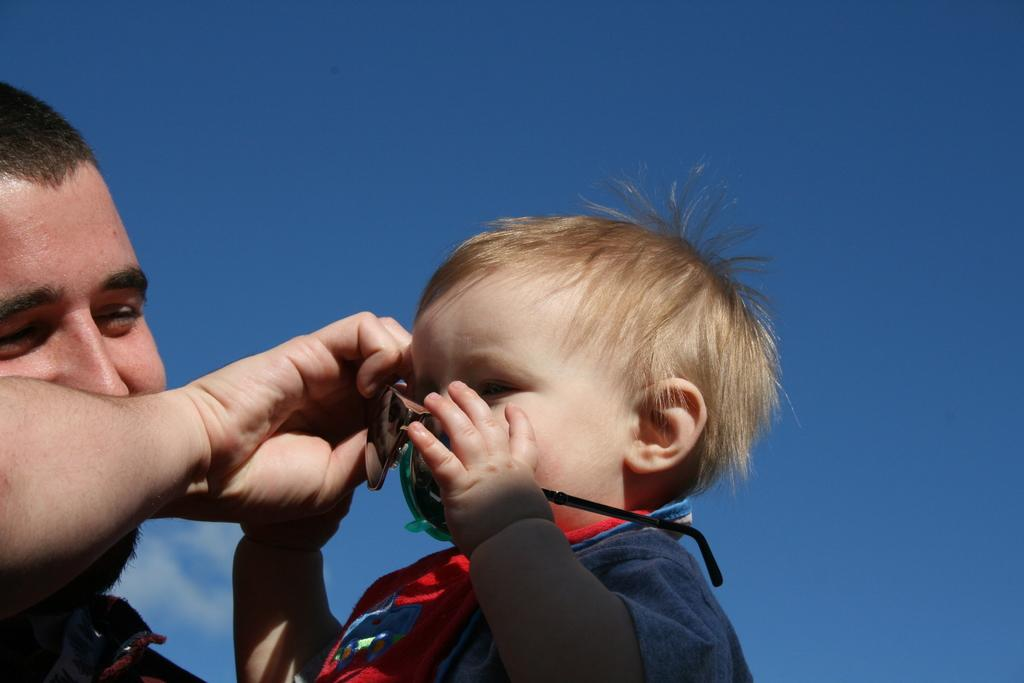Who is present in the image? There is a boy and a person in the image. Can you describe the boy in the image? The facts provided do not give specific details about the boy's appearance or actions. What is visible in the background of the image? The sky is visible in the background of the image. Where is the throne located in the image? There is no throne present in the image. What type of stocking is the person wearing in the image? The facts provided do not give specific details about the person's clothing or accessories. 